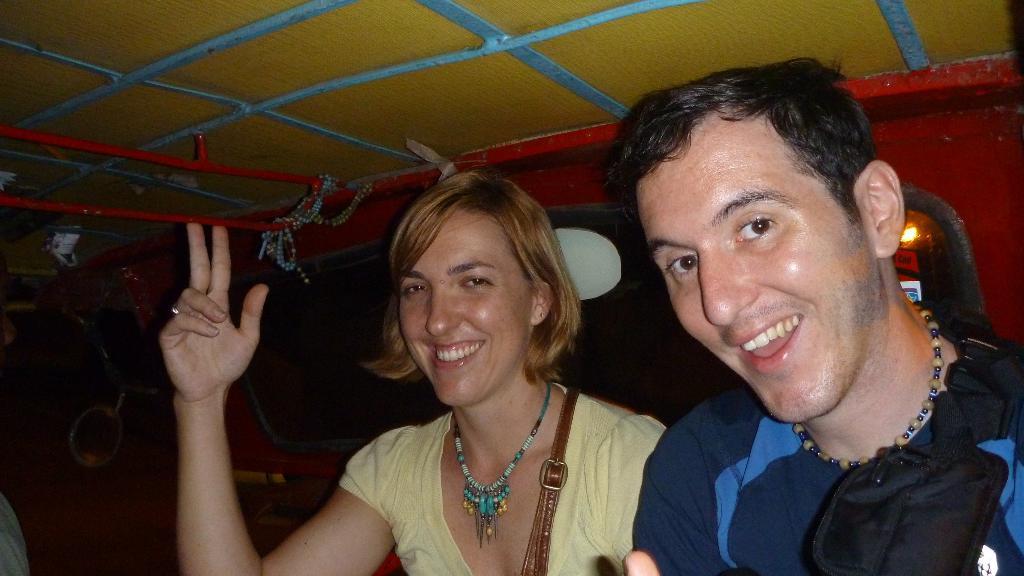Describe this image in one or two sentences. In the center of the image we can see two people are smiling and a lady is wearing a bag. In the background of the image we can see the windows, light, board. At the top of the image we can see the roof and rod. 